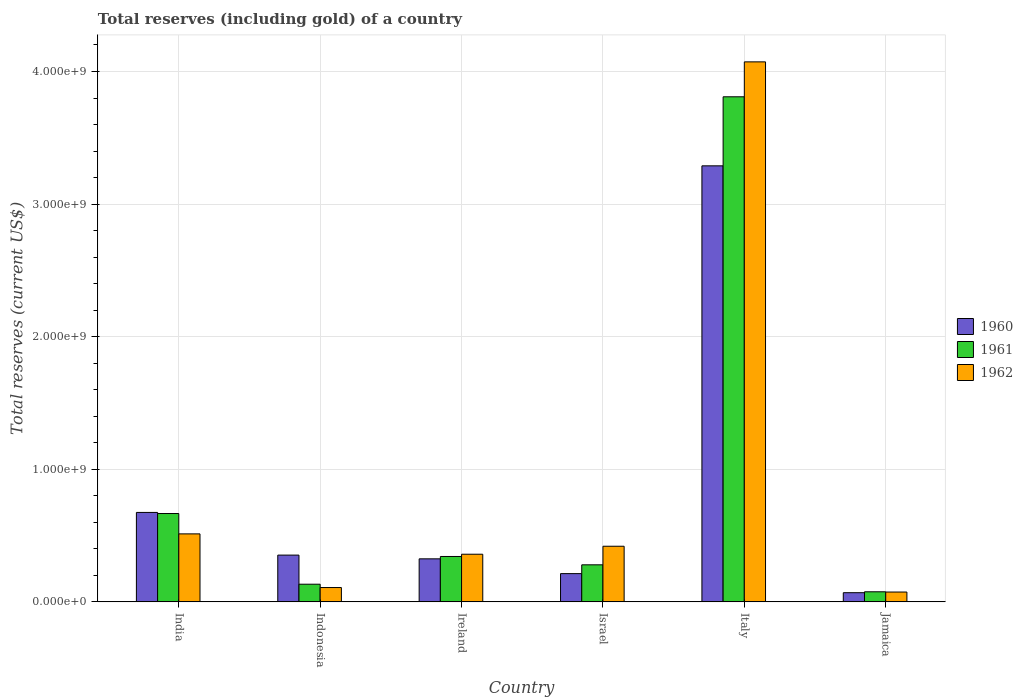How many different coloured bars are there?
Provide a succinct answer. 3. How many groups of bars are there?
Your response must be concise. 6. How many bars are there on the 2nd tick from the right?
Give a very brief answer. 3. What is the label of the 4th group of bars from the left?
Give a very brief answer. Israel. In how many cases, is the number of bars for a given country not equal to the number of legend labels?
Ensure brevity in your answer.  0. What is the total reserves (including gold) in 1961 in Jamaica?
Your response must be concise. 7.61e+07. Across all countries, what is the maximum total reserves (including gold) in 1962?
Your answer should be very brief. 4.07e+09. Across all countries, what is the minimum total reserves (including gold) in 1960?
Provide a succinct answer. 6.92e+07. In which country was the total reserves (including gold) in 1962 minimum?
Your answer should be compact. Jamaica. What is the total total reserves (including gold) in 1960 in the graph?
Your response must be concise. 4.92e+09. What is the difference between the total reserves (including gold) in 1960 in Indonesia and that in Italy?
Keep it short and to the point. -2.94e+09. What is the difference between the total reserves (including gold) in 1960 in Ireland and the total reserves (including gold) in 1962 in Italy?
Offer a very short reply. -3.75e+09. What is the average total reserves (including gold) in 1961 per country?
Ensure brevity in your answer.  8.84e+08. What is the difference between the total reserves (including gold) of/in 1961 and total reserves (including gold) of/in 1960 in Indonesia?
Your response must be concise. -2.20e+08. In how many countries, is the total reserves (including gold) in 1960 greater than 1800000000 US$?
Your response must be concise. 1. What is the ratio of the total reserves (including gold) in 1961 in Italy to that in Jamaica?
Your response must be concise. 50.06. Is the difference between the total reserves (including gold) in 1961 in Indonesia and Italy greater than the difference between the total reserves (including gold) in 1960 in Indonesia and Italy?
Make the answer very short. No. What is the difference between the highest and the second highest total reserves (including gold) in 1960?
Make the answer very short. -3.22e+08. What is the difference between the highest and the lowest total reserves (including gold) in 1962?
Your response must be concise. 4.00e+09. Is the sum of the total reserves (including gold) in 1960 in India and Ireland greater than the maximum total reserves (including gold) in 1961 across all countries?
Give a very brief answer. No. How many bars are there?
Make the answer very short. 18. How many countries are there in the graph?
Provide a succinct answer. 6. Are the values on the major ticks of Y-axis written in scientific E-notation?
Keep it short and to the point. Yes. Does the graph contain any zero values?
Make the answer very short. No. Does the graph contain grids?
Offer a terse response. Yes. Where does the legend appear in the graph?
Keep it short and to the point. Center right. How many legend labels are there?
Offer a terse response. 3. What is the title of the graph?
Provide a succinct answer. Total reserves (including gold) of a country. What is the label or title of the X-axis?
Offer a very short reply. Country. What is the label or title of the Y-axis?
Your answer should be very brief. Total reserves (current US$). What is the Total reserves (current US$) of 1960 in India?
Your answer should be compact. 6.75e+08. What is the Total reserves (current US$) of 1961 in India?
Provide a succinct answer. 6.66e+08. What is the Total reserves (current US$) of 1962 in India?
Offer a very short reply. 5.13e+08. What is the Total reserves (current US$) of 1960 in Indonesia?
Ensure brevity in your answer.  3.53e+08. What is the Total reserves (current US$) of 1961 in Indonesia?
Ensure brevity in your answer.  1.33e+08. What is the Total reserves (current US$) in 1962 in Indonesia?
Provide a succinct answer. 1.08e+08. What is the Total reserves (current US$) of 1960 in Ireland?
Your response must be concise. 3.25e+08. What is the Total reserves (current US$) of 1961 in Ireland?
Provide a succinct answer. 3.42e+08. What is the Total reserves (current US$) in 1962 in Ireland?
Make the answer very short. 3.59e+08. What is the Total reserves (current US$) of 1960 in Israel?
Your answer should be compact. 2.13e+08. What is the Total reserves (current US$) in 1961 in Israel?
Make the answer very short. 2.80e+08. What is the Total reserves (current US$) in 1962 in Israel?
Provide a short and direct response. 4.20e+08. What is the Total reserves (current US$) of 1960 in Italy?
Make the answer very short. 3.29e+09. What is the Total reserves (current US$) of 1961 in Italy?
Your answer should be compact. 3.81e+09. What is the Total reserves (current US$) in 1962 in Italy?
Ensure brevity in your answer.  4.07e+09. What is the Total reserves (current US$) in 1960 in Jamaica?
Ensure brevity in your answer.  6.92e+07. What is the Total reserves (current US$) of 1961 in Jamaica?
Keep it short and to the point. 7.61e+07. What is the Total reserves (current US$) in 1962 in Jamaica?
Keep it short and to the point. 7.42e+07. Across all countries, what is the maximum Total reserves (current US$) in 1960?
Keep it short and to the point. 3.29e+09. Across all countries, what is the maximum Total reserves (current US$) of 1961?
Your response must be concise. 3.81e+09. Across all countries, what is the maximum Total reserves (current US$) of 1962?
Your answer should be compact. 4.07e+09. Across all countries, what is the minimum Total reserves (current US$) of 1960?
Make the answer very short. 6.92e+07. Across all countries, what is the minimum Total reserves (current US$) of 1961?
Give a very brief answer. 7.61e+07. Across all countries, what is the minimum Total reserves (current US$) in 1962?
Provide a succinct answer. 7.42e+07. What is the total Total reserves (current US$) in 1960 in the graph?
Keep it short and to the point. 4.92e+09. What is the total Total reserves (current US$) in 1961 in the graph?
Keep it short and to the point. 5.31e+09. What is the total Total reserves (current US$) of 1962 in the graph?
Keep it short and to the point. 5.55e+09. What is the difference between the Total reserves (current US$) of 1960 in India and that in Indonesia?
Your answer should be compact. 3.22e+08. What is the difference between the Total reserves (current US$) of 1961 in India and that in Indonesia?
Keep it short and to the point. 5.33e+08. What is the difference between the Total reserves (current US$) of 1962 in India and that in Indonesia?
Give a very brief answer. 4.05e+08. What is the difference between the Total reserves (current US$) of 1960 in India and that in Ireland?
Your answer should be compact. 3.50e+08. What is the difference between the Total reserves (current US$) of 1961 in India and that in Ireland?
Keep it short and to the point. 3.24e+08. What is the difference between the Total reserves (current US$) in 1962 in India and that in Ireland?
Make the answer very short. 1.53e+08. What is the difference between the Total reserves (current US$) of 1960 in India and that in Israel?
Keep it short and to the point. 4.61e+08. What is the difference between the Total reserves (current US$) of 1961 in India and that in Israel?
Keep it short and to the point. 3.87e+08. What is the difference between the Total reserves (current US$) in 1962 in India and that in Israel?
Offer a terse response. 9.32e+07. What is the difference between the Total reserves (current US$) in 1960 in India and that in Italy?
Keep it short and to the point. -2.61e+09. What is the difference between the Total reserves (current US$) of 1961 in India and that in Italy?
Offer a terse response. -3.14e+09. What is the difference between the Total reserves (current US$) in 1962 in India and that in Italy?
Provide a short and direct response. -3.56e+09. What is the difference between the Total reserves (current US$) in 1960 in India and that in Jamaica?
Your response must be concise. 6.05e+08. What is the difference between the Total reserves (current US$) of 1961 in India and that in Jamaica?
Make the answer very short. 5.90e+08. What is the difference between the Total reserves (current US$) in 1962 in India and that in Jamaica?
Your answer should be very brief. 4.39e+08. What is the difference between the Total reserves (current US$) in 1960 in Indonesia and that in Ireland?
Offer a terse response. 2.82e+07. What is the difference between the Total reserves (current US$) in 1961 in Indonesia and that in Ireland?
Provide a succinct answer. -2.09e+08. What is the difference between the Total reserves (current US$) in 1962 in Indonesia and that in Ireland?
Ensure brevity in your answer.  -2.51e+08. What is the difference between the Total reserves (current US$) of 1960 in Indonesia and that in Israel?
Offer a very short reply. 1.40e+08. What is the difference between the Total reserves (current US$) in 1961 in Indonesia and that in Israel?
Offer a very short reply. -1.46e+08. What is the difference between the Total reserves (current US$) in 1962 in Indonesia and that in Israel?
Provide a short and direct response. -3.12e+08. What is the difference between the Total reserves (current US$) in 1960 in Indonesia and that in Italy?
Your answer should be very brief. -2.94e+09. What is the difference between the Total reserves (current US$) in 1961 in Indonesia and that in Italy?
Provide a short and direct response. -3.68e+09. What is the difference between the Total reserves (current US$) of 1962 in Indonesia and that in Italy?
Provide a short and direct response. -3.96e+09. What is the difference between the Total reserves (current US$) in 1960 in Indonesia and that in Jamaica?
Ensure brevity in your answer.  2.84e+08. What is the difference between the Total reserves (current US$) of 1961 in Indonesia and that in Jamaica?
Ensure brevity in your answer.  5.71e+07. What is the difference between the Total reserves (current US$) of 1962 in Indonesia and that in Jamaica?
Offer a terse response. 3.39e+07. What is the difference between the Total reserves (current US$) in 1960 in Ireland and that in Israel?
Provide a short and direct response. 1.11e+08. What is the difference between the Total reserves (current US$) in 1961 in Ireland and that in Israel?
Provide a short and direct response. 6.28e+07. What is the difference between the Total reserves (current US$) of 1962 in Ireland and that in Israel?
Offer a terse response. -6.03e+07. What is the difference between the Total reserves (current US$) of 1960 in Ireland and that in Italy?
Ensure brevity in your answer.  -2.96e+09. What is the difference between the Total reserves (current US$) in 1961 in Ireland and that in Italy?
Provide a short and direct response. -3.47e+09. What is the difference between the Total reserves (current US$) in 1962 in Ireland and that in Italy?
Keep it short and to the point. -3.71e+09. What is the difference between the Total reserves (current US$) of 1960 in Ireland and that in Jamaica?
Give a very brief answer. 2.55e+08. What is the difference between the Total reserves (current US$) in 1961 in Ireland and that in Jamaica?
Offer a terse response. 2.66e+08. What is the difference between the Total reserves (current US$) in 1962 in Ireland and that in Jamaica?
Offer a terse response. 2.85e+08. What is the difference between the Total reserves (current US$) in 1960 in Israel and that in Italy?
Provide a short and direct response. -3.08e+09. What is the difference between the Total reserves (current US$) in 1961 in Israel and that in Italy?
Your response must be concise. -3.53e+09. What is the difference between the Total reserves (current US$) of 1962 in Israel and that in Italy?
Your response must be concise. -3.65e+09. What is the difference between the Total reserves (current US$) in 1960 in Israel and that in Jamaica?
Give a very brief answer. 1.44e+08. What is the difference between the Total reserves (current US$) in 1961 in Israel and that in Jamaica?
Provide a short and direct response. 2.03e+08. What is the difference between the Total reserves (current US$) of 1962 in Israel and that in Jamaica?
Ensure brevity in your answer.  3.45e+08. What is the difference between the Total reserves (current US$) of 1960 in Italy and that in Jamaica?
Offer a terse response. 3.22e+09. What is the difference between the Total reserves (current US$) in 1961 in Italy and that in Jamaica?
Ensure brevity in your answer.  3.73e+09. What is the difference between the Total reserves (current US$) in 1962 in Italy and that in Jamaica?
Your answer should be compact. 4.00e+09. What is the difference between the Total reserves (current US$) of 1960 in India and the Total reserves (current US$) of 1961 in Indonesia?
Provide a short and direct response. 5.41e+08. What is the difference between the Total reserves (current US$) of 1960 in India and the Total reserves (current US$) of 1962 in Indonesia?
Keep it short and to the point. 5.66e+08. What is the difference between the Total reserves (current US$) of 1961 in India and the Total reserves (current US$) of 1962 in Indonesia?
Offer a terse response. 5.58e+08. What is the difference between the Total reserves (current US$) in 1960 in India and the Total reserves (current US$) in 1961 in Ireland?
Offer a very short reply. 3.32e+08. What is the difference between the Total reserves (current US$) of 1960 in India and the Total reserves (current US$) of 1962 in Ireland?
Make the answer very short. 3.15e+08. What is the difference between the Total reserves (current US$) of 1961 in India and the Total reserves (current US$) of 1962 in Ireland?
Offer a very short reply. 3.07e+08. What is the difference between the Total reserves (current US$) in 1960 in India and the Total reserves (current US$) in 1961 in Israel?
Keep it short and to the point. 3.95e+08. What is the difference between the Total reserves (current US$) of 1960 in India and the Total reserves (current US$) of 1962 in Israel?
Provide a succinct answer. 2.55e+08. What is the difference between the Total reserves (current US$) in 1961 in India and the Total reserves (current US$) in 1962 in Israel?
Offer a very short reply. 2.47e+08. What is the difference between the Total reserves (current US$) in 1960 in India and the Total reserves (current US$) in 1961 in Italy?
Give a very brief answer. -3.13e+09. What is the difference between the Total reserves (current US$) of 1960 in India and the Total reserves (current US$) of 1962 in Italy?
Ensure brevity in your answer.  -3.40e+09. What is the difference between the Total reserves (current US$) of 1961 in India and the Total reserves (current US$) of 1962 in Italy?
Your response must be concise. -3.41e+09. What is the difference between the Total reserves (current US$) of 1960 in India and the Total reserves (current US$) of 1961 in Jamaica?
Provide a succinct answer. 5.98e+08. What is the difference between the Total reserves (current US$) in 1960 in India and the Total reserves (current US$) in 1962 in Jamaica?
Your answer should be compact. 6.00e+08. What is the difference between the Total reserves (current US$) of 1961 in India and the Total reserves (current US$) of 1962 in Jamaica?
Offer a terse response. 5.92e+08. What is the difference between the Total reserves (current US$) of 1960 in Indonesia and the Total reserves (current US$) of 1961 in Ireland?
Provide a succinct answer. 1.04e+07. What is the difference between the Total reserves (current US$) of 1960 in Indonesia and the Total reserves (current US$) of 1962 in Ireland?
Give a very brief answer. -6.56e+06. What is the difference between the Total reserves (current US$) of 1961 in Indonesia and the Total reserves (current US$) of 1962 in Ireland?
Your response must be concise. -2.26e+08. What is the difference between the Total reserves (current US$) of 1960 in Indonesia and the Total reserves (current US$) of 1961 in Israel?
Provide a succinct answer. 7.32e+07. What is the difference between the Total reserves (current US$) of 1960 in Indonesia and the Total reserves (current US$) of 1962 in Israel?
Provide a succinct answer. -6.69e+07. What is the difference between the Total reserves (current US$) in 1961 in Indonesia and the Total reserves (current US$) in 1962 in Israel?
Your answer should be very brief. -2.86e+08. What is the difference between the Total reserves (current US$) in 1960 in Indonesia and the Total reserves (current US$) in 1961 in Italy?
Your answer should be compact. -3.46e+09. What is the difference between the Total reserves (current US$) in 1960 in Indonesia and the Total reserves (current US$) in 1962 in Italy?
Give a very brief answer. -3.72e+09. What is the difference between the Total reserves (current US$) of 1961 in Indonesia and the Total reserves (current US$) of 1962 in Italy?
Provide a short and direct response. -3.94e+09. What is the difference between the Total reserves (current US$) of 1960 in Indonesia and the Total reserves (current US$) of 1961 in Jamaica?
Your response must be concise. 2.77e+08. What is the difference between the Total reserves (current US$) of 1960 in Indonesia and the Total reserves (current US$) of 1962 in Jamaica?
Your response must be concise. 2.79e+08. What is the difference between the Total reserves (current US$) in 1961 in Indonesia and the Total reserves (current US$) in 1962 in Jamaica?
Offer a very short reply. 5.90e+07. What is the difference between the Total reserves (current US$) of 1960 in Ireland and the Total reserves (current US$) of 1961 in Israel?
Your response must be concise. 4.51e+07. What is the difference between the Total reserves (current US$) of 1960 in Ireland and the Total reserves (current US$) of 1962 in Israel?
Make the answer very short. -9.51e+07. What is the difference between the Total reserves (current US$) in 1961 in Ireland and the Total reserves (current US$) in 1962 in Israel?
Provide a short and direct response. -7.73e+07. What is the difference between the Total reserves (current US$) of 1960 in Ireland and the Total reserves (current US$) of 1961 in Italy?
Provide a succinct answer. -3.48e+09. What is the difference between the Total reserves (current US$) in 1960 in Ireland and the Total reserves (current US$) in 1962 in Italy?
Keep it short and to the point. -3.75e+09. What is the difference between the Total reserves (current US$) of 1961 in Ireland and the Total reserves (current US$) of 1962 in Italy?
Keep it short and to the point. -3.73e+09. What is the difference between the Total reserves (current US$) in 1960 in Ireland and the Total reserves (current US$) in 1961 in Jamaica?
Offer a terse response. 2.48e+08. What is the difference between the Total reserves (current US$) of 1960 in Ireland and the Total reserves (current US$) of 1962 in Jamaica?
Give a very brief answer. 2.50e+08. What is the difference between the Total reserves (current US$) of 1961 in Ireland and the Total reserves (current US$) of 1962 in Jamaica?
Provide a succinct answer. 2.68e+08. What is the difference between the Total reserves (current US$) in 1960 in Israel and the Total reserves (current US$) in 1961 in Italy?
Ensure brevity in your answer.  -3.60e+09. What is the difference between the Total reserves (current US$) of 1960 in Israel and the Total reserves (current US$) of 1962 in Italy?
Your answer should be compact. -3.86e+09. What is the difference between the Total reserves (current US$) in 1961 in Israel and the Total reserves (current US$) in 1962 in Italy?
Provide a succinct answer. -3.79e+09. What is the difference between the Total reserves (current US$) in 1960 in Israel and the Total reserves (current US$) in 1961 in Jamaica?
Offer a terse response. 1.37e+08. What is the difference between the Total reserves (current US$) of 1960 in Israel and the Total reserves (current US$) of 1962 in Jamaica?
Give a very brief answer. 1.39e+08. What is the difference between the Total reserves (current US$) in 1961 in Israel and the Total reserves (current US$) in 1962 in Jamaica?
Your response must be concise. 2.05e+08. What is the difference between the Total reserves (current US$) of 1960 in Italy and the Total reserves (current US$) of 1961 in Jamaica?
Provide a succinct answer. 3.21e+09. What is the difference between the Total reserves (current US$) in 1960 in Italy and the Total reserves (current US$) in 1962 in Jamaica?
Offer a very short reply. 3.21e+09. What is the difference between the Total reserves (current US$) of 1961 in Italy and the Total reserves (current US$) of 1962 in Jamaica?
Provide a succinct answer. 3.74e+09. What is the average Total reserves (current US$) of 1960 per country?
Ensure brevity in your answer.  8.20e+08. What is the average Total reserves (current US$) of 1961 per country?
Your answer should be very brief. 8.84e+08. What is the average Total reserves (current US$) in 1962 per country?
Provide a succinct answer. 9.24e+08. What is the difference between the Total reserves (current US$) of 1960 and Total reserves (current US$) of 1961 in India?
Offer a terse response. 8.18e+06. What is the difference between the Total reserves (current US$) of 1960 and Total reserves (current US$) of 1962 in India?
Your answer should be very brief. 1.62e+08. What is the difference between the Total reserves (current US$) in 1961 and Total reserves (current US$) in 1962 in India?
Provide a short and direct response. 1.54e+08. What is the difference between the Total reserves (current US$) of 1960 and Total reserves (current US$) of 1961 in Indonesia?
Your response must be concise. 2.20e+08. What is the difference between the Total reserves (current US$) in 1960 and Total reserves (current US$) in 1962 in Indonesia?
Offer a very short reply. 2.45e+08. What is the difference between the Total reserves (current US$) in 1961 and Total reserves (current US$) in 1962 in Indonesia?
Your answer should be compact. 2.51e+07. What is the difference between the Total reserves (current US$) in 1960 and Total reserves (current US$) in 1961 in Ireland?
Keep it short and to the point. -1.78e+07. What is the difference between the Total reserves (current US$) in 1960 and Total reserves (current US$) in 1962 in Ireland?
Provide a succinct answer. -3.47e+07. What is the difference between the Total reserves (current US$) in 1961 and Total reserves (current US$) in 1962 in Ireland?
Offer a very short reply. -1.70e+07. What is the difference between the Total reserves (current US$) of 1960 and Total reserves (current US$) of 1961 in Israel?
Provide a succinct answer. -6.64e+07. What is the difference between the Total reserves (current US$) of 1960 and Total reserves (current US$) of 1962 in Israel?
Ensure brevity in your answer.  -2.06e+08. What is the difference between the Total reserves (current US$) of 1961 and Total reserves (current US$) of 1962 in Israel?
Ensure brevity in your answer.  -1.40e+08. What is the difference between the Total reserves (current US$) in 1960 and Total reserves (current US$) in 1961 in Italy?
Give a very brief answer. -5.21e+08. What is the difference between the Total reserves (current US$) in 1960 and Total reserves (current US$) in 1962 in Italy?
Keep it short and to the point. -7.84e+08. What is the difference between the Total reserves (current US$) of 1961 and Total reserves (current US$) of 1962 in Italy?
Make the answer very short. -2.63e+08. What is the difference between the Total reserves (current US$) of 1960 and Total reserves (current US$) of 1961 in Jamaica?
Provide a succinct answer. -6.90e+06. What is the difference between the Total reserves (current US$) of 1960 and Total reserves (current US$) of 1962 in Jamaica?
Your answer should be compact. -5.00e+06. What is the difference between the Total reserves (current US$) in 1961 and Total reserves (current US$) in 1962 in Jamaica?
Provide a succinct answer. 1.90e+06. What is the ratio of the Total reserves (current US$) in 1960 in India to that in Indonesia?
Offer a very short reply. 1.91. What is the ratio of the Total reserves (current US$) in 1961 in India to that in Indonesia?
Your response must be concise. 5. What is the ratio of the Total reserves (current US$) of 1962 in India to that in Indonesia?
Your response must be concise. 4.74. What is the ratio of the Total reserves (current US$) of 1960 in India to that in Ireland?
Provide a succinct answer. 2.08. What is the ratio of the Total reserves (current US$) in 1961 in India to that in Ireland?
Ensure brevity in your answer.  1.95. What is the ratio of the Total reserves (current US$) in 1962 in India to that in Ireland?
Keep it short and to the point. 1.43. What is the ratio of the Total reserves (current US$) of 1960 in India to that in Israel?
Your answer should be very brief. 3.16. What is the ratio of the Total reserves (current US$) of 1961 in India to that in Israel?
Provide a short and direct response. 2.38. What is the ratio of the Total reserves (current US$) in 1962 in India to that in Israel?
Provide a short and direct response. 1.22. What is the ratio of the Total reserves (current US$) in 1960 in India to that in Italy?
Your answer should be compact. 0.21. What is the ratio of the Total reserves (current US$) of 1961 in India to that in Italy?
Keep it short and to the point. 0.17. What is the ratio of the Total reserves (current US$) of 1962 in India to that in Italy?
Make the answer very short. 0.13. What is the ratio of the Total reserves (current US$) of 1960 in India to that in Jamaica?
Your answer should be very brief. 9.75. What is the ratio of the Total reserves (current US$) of 1961 in India to that in Jamaica?
Your response must be concise. 8.76. What is the ratio of the Total reserves (current US$) of 1962 in India to that in Jamaica?
Your response must be concise. 6.91. What is the ratio of the Total reserves (current US$) in 1960 in Indonesia to that in Ireland?
Provide a short and direct response. 1.09. What is the ratio of the Total reserves (current US$) in 1961 in Indonesia to that in Ireland?
Ensure brevity in your answer.  0.39. What is the ratio of the Total reserves (current US$) of 1962 in Indonesia to that in Ireland?
Offer a terse response. 0.3. What is the ratio of the Total reserves (current US$) in 1960 in Indonesia to that in Israel?
Keep it short and to the point. 1.65. What is the ratio of the Total reserves (current US$) of 1961 in Indonesia to that in Israel?
Offer a very short reply. 0.48. What is the ratio of the Total reserves (current US$) of 1962 in Indonesia to that in Israel?
Keep it short and to the point. 0.26. What is the ratio of the Total reserves (current US$) in 1960 in Indonesia to that in Italy?
Make the answer very short. 0.11. What is the ratio of the Total reserves (current US$) of 1961 in Indonesia to that in Italy?
Keep it short and to the point. 0.04. What is the ratio of the Total reserves (current US$) in 1962 in Indonesia to that in Italy?
Make the answer very short. 0.03. What is the ratio of the Total reserves (current US$) in 1960 in Indonesia to that in Jamaica?
Offer a terse response. 5.1. What is the ratio of the Total reserves (current US$) of 1961 in Indonesia to that in Jamaica?
Provide a succinct answer. 1.75. What is the ratio of the Total reserves (current US$) in 1962 in Indonesia to that in Jamaica?
Your answer should be very brief. 1.46. What is the ratio of the Total reserves (current US$) of 1960 in Ireland to that in Israel?
Your answer should be compact. 1.52. What is the ratio of the Total reserves (current US$) in 1961 in Ireland to that in Israel?
Provide a succinct answer. 1.22. What is the ratio of the Total reserves (current US$) of 1962 in Ireland to that in Israel?
Your response must be concise. 0.86. What is the ratio of the Total reserves (current US$) of 1960 in Ireland to that in Italy?
Your answer should be compact. 0.1. What is the ratio of the Total reserves (current US$) in 1961 in Ireland to that in Italy?
Keep it short and to the point. 0.09. What is the ratio of the Total reserves (current US$) in 1962 in Ireland to that in Italy?
Provide a short and direct response. 0.09. What is the ratio of the Total reserves (current US$) in 1960 in Ireland to that in Jamaica?
Your answer should be compact. 4.69. What is the ratio of the Total reserves (current US$) of 1961 in Ireland to that in Jamaica?
Your response must be concise. 4.5. What is the ratio of the Total reserves (current US$) of 1962 in Ireland to that in Jamaica?
Your response must be concise. 4.84. What is the ratio of the Total reserves (current US$) in 1960 in Israel to that in Italy?
Your answer should be compact. 0.06. What is the ratio of the Total reserves (current US$) of 1961 in Israel to that in Italy?
Your answer should be compact. 0.07. What is the ratio of the Total reserves (current US$) in 1962 in Israel to that in Italy?
Your answer should be compact. 0.1. What is the ratio of the Total reserves (current US$) of 1960 in Israel to that in Jamaica?
Give a very brief answer. 3.08. What is the ratio of the Total reserves (current US$) of 1961 in Israel to that in Jamaica?
Ensure brevity in your answer.  3.67. What is the ratio of the Total reserves (current US$) in 1962 in Israel to that in Jamaica?
Your response must be concise. 5.66. What is the ratio of the Total reserves (current US$) of 1960 in Italy to that in Jamaica?
Ensure brevity in your answer.  47.52. What is the ratio of the Total reserves (current US$) of 1961 in Italy to that in Jamaica?
Offer a very short reply. 50.06. What is the ratio of the Total reserves (current US$) of 1962 in Italy to that in Jamaica?
Provide a short and direct response. 54.89. What is the difference between the highest and the second highest Total reserves (current US$) in 1960?
Your answer should be very brief. 2.61e+09. What is the difference between the highest and the second highest Total reserves (current US$) in 1961?
Your response must be concise. 3.14e+09. What is the difference between the highest and the second highest Total reserves (current US$) of 1962?
Make the answer very short. 3.56e+09. What is the difference between the highest and the lowest Total reserves (current US$) of 1960?
Make the answer very short. 3.22e+09. What is the difference between the highest and the lowest Total reserves (current US$) in 1961?
Your answer should be compact. 3.73e+09. What is the difference between the highest and the lowest Total reserves (current US$) in 1962?
Give a very brief answer. 4.00e+09. 